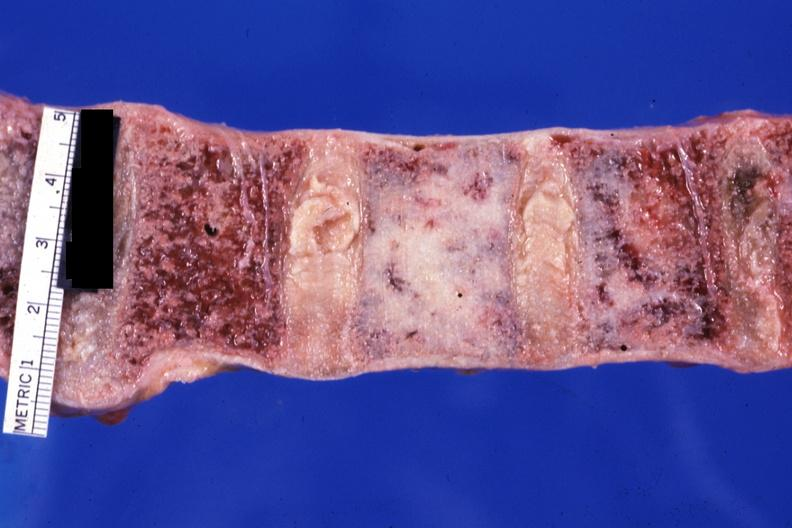what does this image show?
Answer the question using a single word or phrase. Close-up looks like ivory vertebra of breast carcinoma 